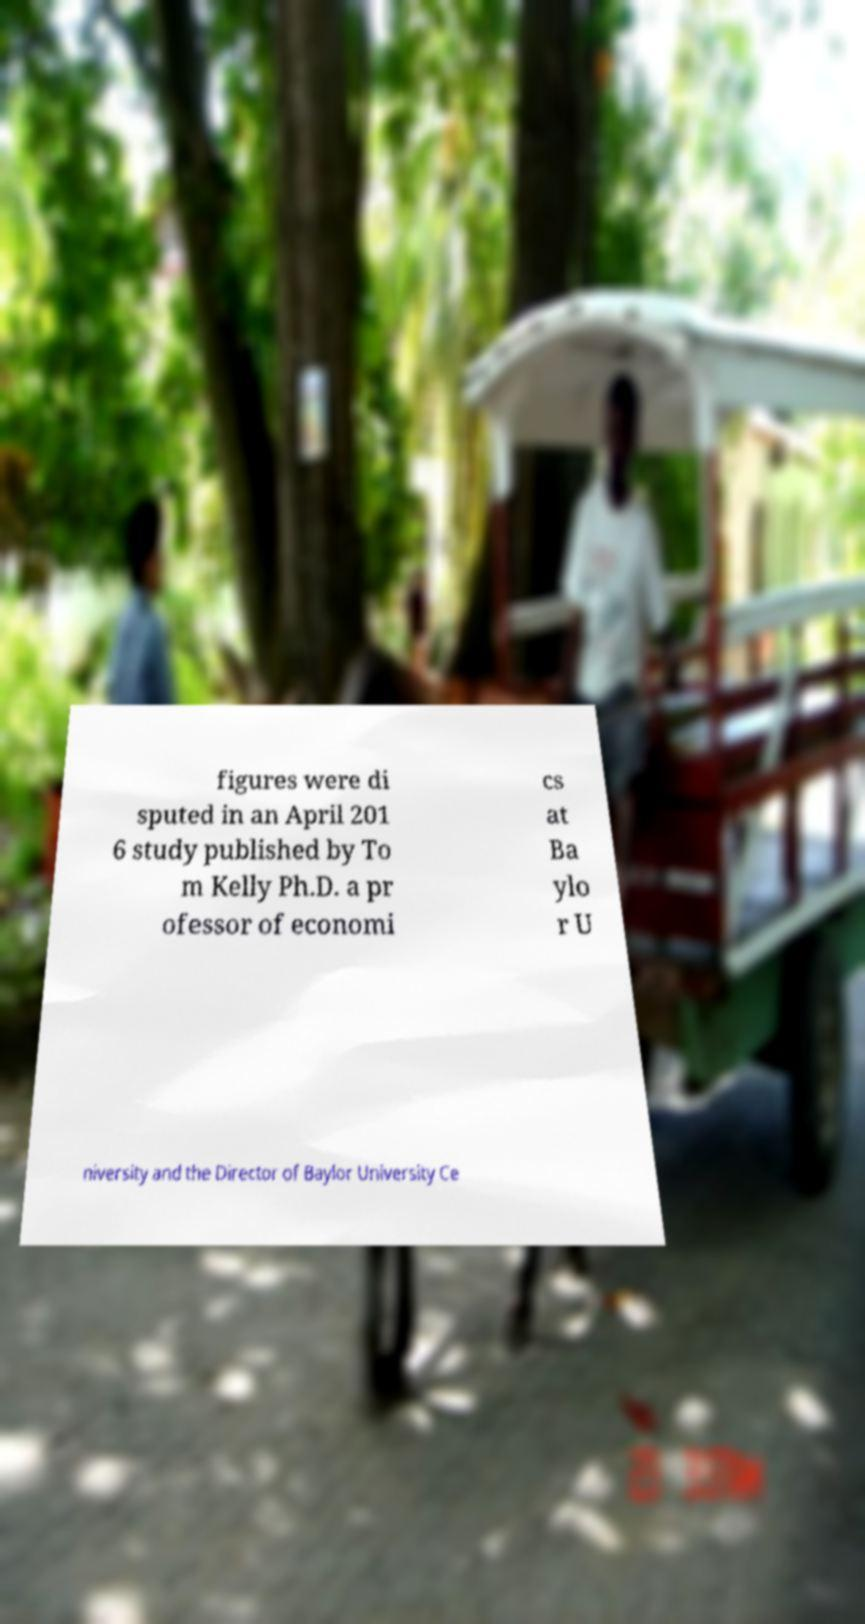Please identify and transcribe the text found in this image. figures were di sputed in an April 201 6 study published by To m Kelly Ph.D. a pr ofessor of economi cs at Ba ylo r U niversity and the Director of Baylor University Ce 